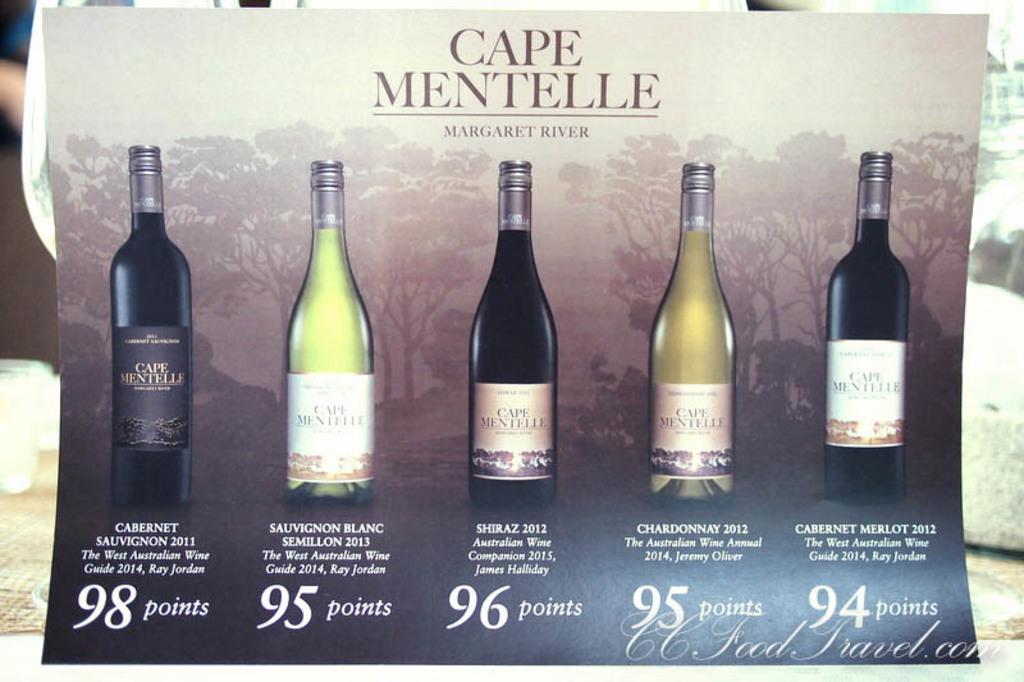What brand is this?
Your response must be concise. Cape mentelle. 